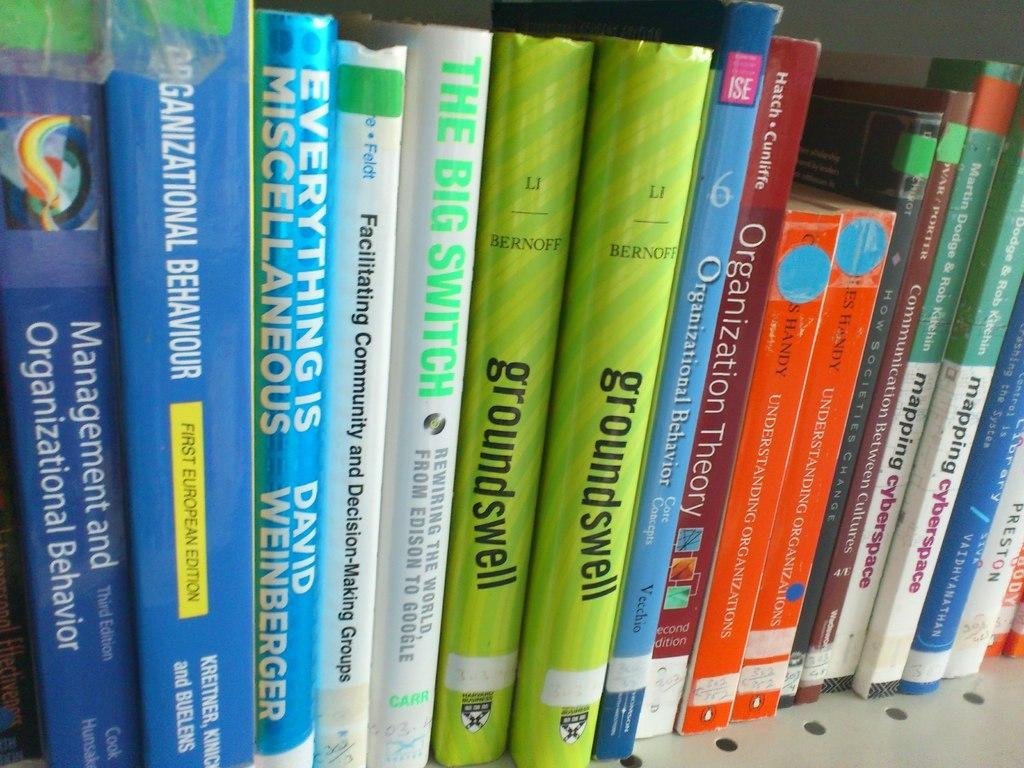<image>
Provide a brief description of the given image. a shelf of books, one of them says groundswell. 